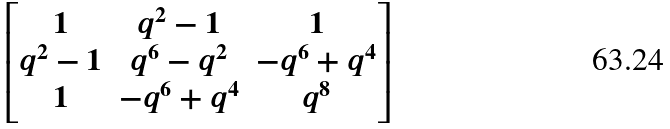Convert formula to latex. <formula><loc_0><loc_0><loc_500><loc_500>\begin{bmatrix} 1 & q ^ { 2 } - 1 & 1 \\ q ^ { 2 } - 1 & q ^ { 6 } - q ^ { 2 } & - q ^ { 6 } + q ^ { 4 } \\ 1 & - q ^ { 6 } + q ^ { 4 } & q ^ { 8 } \end{bmatrix}</formula> 